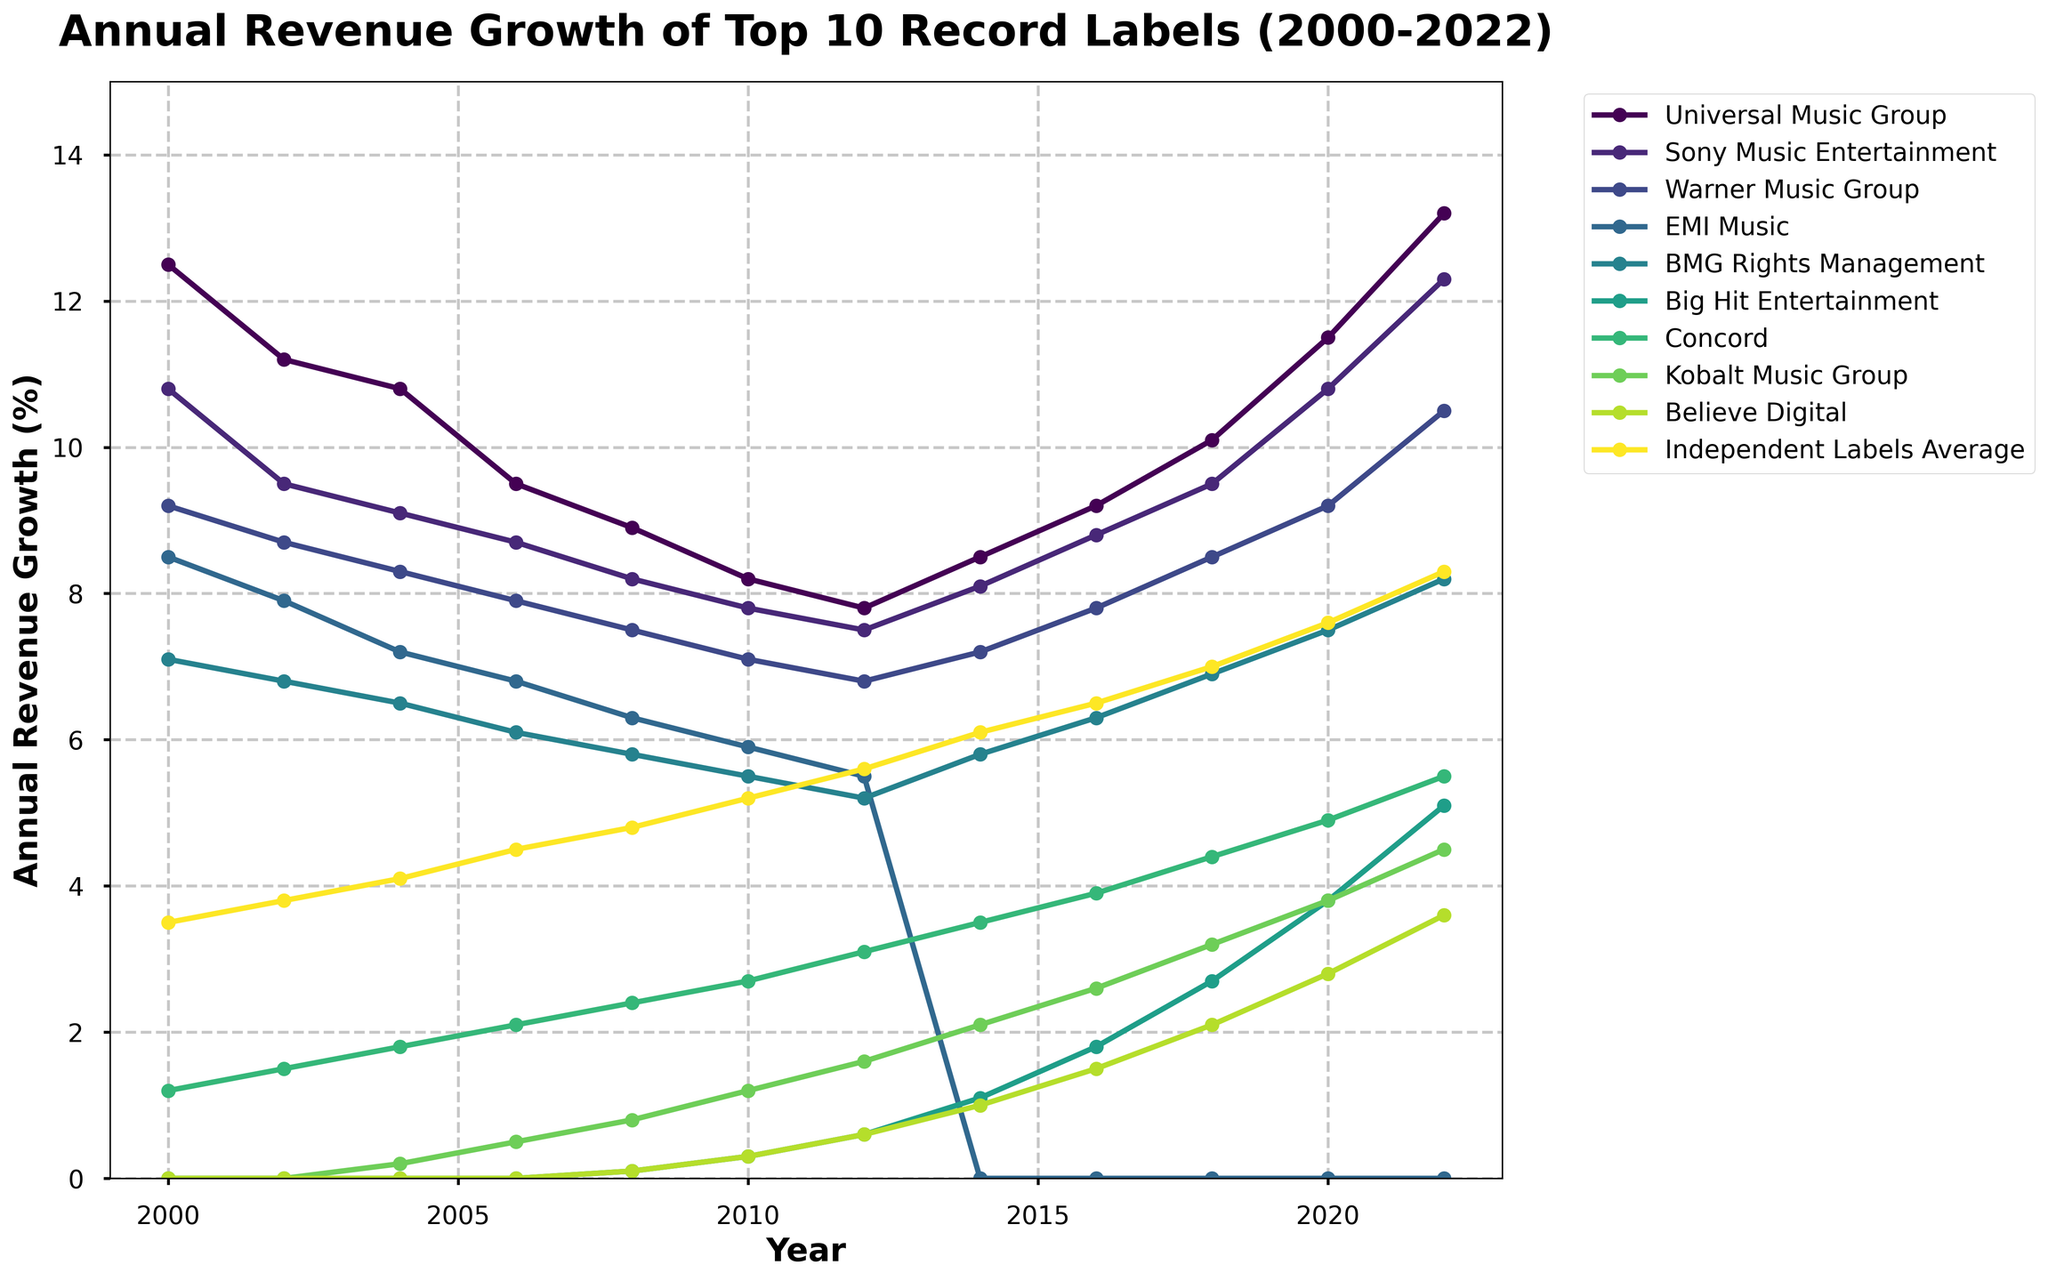Which record label had the highest revenue growth in 2022? Check the graph for the highest point in 2022, which is labeled accordingly. The highest line in 2022 is Universal Music Group.
Answer: Universal Music Group How did the revenue growth for EMI Music change from 2000 to 2010? Locate EMI Music on the graph and observe its decline from 8.5% in 2000 to 5.9% in 2010 using the labels and the trend line.
Answer: Decreased Which record label showed the most consistent revenue growth between 2000 and 2022? Identify the labels with smooth, upward trends without large drops. Universal Music Group shows steady growth over the years.
Answer: Universal Music Group What is the difference in revenue growth between Universal Music Group and Sony Music Entertainment in 2022? In 2022, Universal Music Group is at 13.2% and Sony Music Entertainment is at 12.3%, so the difference is 13.2% - 12.3% = 0.9%.
Answer: 0.9% Which record labels had no revenue growth in 2000 and when did they first appear in the data? The labels with 0.0% in 2000 include Big Hit Entertainment, Kobalt Music Group, and Believe Digital. Kobalt Music Group appears in 2004, Big Hit Entertainment in 2008, Believe Digital in 2008.
Answer: Big Hit Entertainment (2008), Kobalt Music Group (2004), Believe Digital (2008) Which record label experienced the highest growth increase from 2010 to 2022? Compare the slopes from 2010 to 2022 for each record label. Big Hit Entertainment shows the largest increase from 0.3% in 2010 to 5.1% in 2022.
Answer: Big Hit Entertainment How does the average revenue growth of Independent Labels in 2022 compare to Concord? In 2022, Independent Labels Average is at 8.3% and Concord is at 5.5%.
Answer: Higher Which year did Universal Music Group experience a noticeable dip in growth and what was its value then? Universal Music Group's graph shows a dip around 2002, with a value of 11.2%.
Answer: 2002, 11.2% How many record labels had a higher growth rate than 7% in 2020? In 2020, Universal Music Group, Sony Music Entertainment, Warner Music Group, BMG Rights Management, and Independent Labels Average had growth rates above 7%, counting to 5 labels.
Answer: 5 Plot the year when Big Hit Entertainment’s revenue growth surpassed 3.0%. Big Hit Entertainment crossed 3.0% between 2016 and 2018. Specifically in 2018, it reached 2.7% and jumped to 3.8% in 2020.
Answer: 2020 